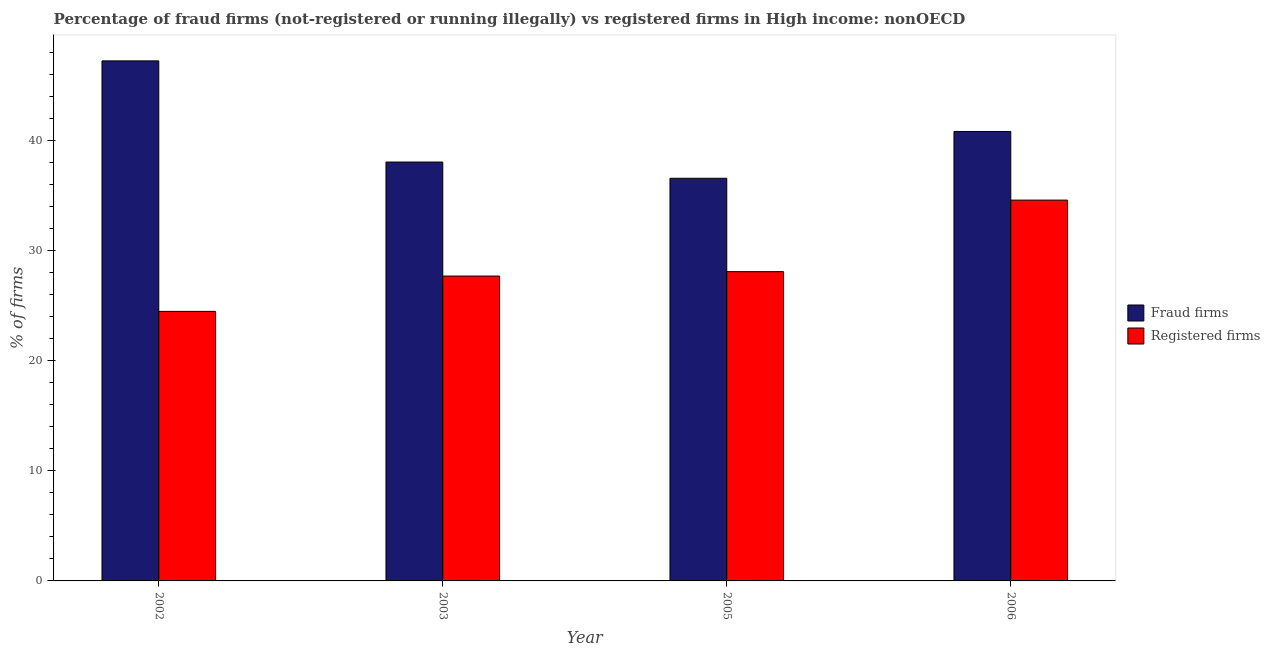Are the number of bars per tick equal to the number of legend labels?
Your response must be concise. Yes. Are the number of bars on each tick of the X-axis equal?
Your answer should be compact. Yes. How many bars are there on the 4th tick from the left?
Give a very brief answer. 2. How many bars are there on the 1st tick from the right?
Ensure brevity in your answer.  2. What is the label of the 1st group of bars from the left?
Keep it short and to the point. 2002. What is the percentage of registered firms in 2002?
Provide a short and direct response. 24.49. Across all years, what is the maximum percentage of fraud firms?
Make the answer very short. 47.25. Across all years, what is the minimum percentage of registered firms?
Provide a short and direct response. 24.49. What is the total percentage of registered firms in the graph?
Provide a succinct answer. 114.89. What is the difference between the percentage of registered firms in 2002 and that in 2005?
Your answer should be very brief. -3.61. What is the difference between the percentage of fraud firms in 2005 and the percentage of registered firms in 2003?
Give a very brief answer. -1.48. What is the average percentage of fraud firms per year?
Provide a succinct answer. 40.68. What is the ratio of the percentage of registered firms in 2003 to that in 2006?
Make the answer very short. 0.8. What is the difference between the highest and the lowest percentage of fraud firms?
Your response must be concise. 10.67. What does the 2nd bar from the left in 2003 represents?
Give a very brief answer. Registered firms. What does the 2nd bar from the right in 2003 represents?
Ensure brevity in your answer.  Fraud firms. How many years are there in the graph?
Your response must be concise. 4. What is the difference between two consecutive major ticks on the Y-axis?
Your response must be concise. 10. Are the values on the major ticks of Y-axis written in scientific E-notation?
Keep it short and to the point. No. Does the graph contain any zero values?
Provide a succinct answer. No. How many legend labels are there?
Your response must be concise. 2. How are the legend labels stacked?
Make the answer very short. Vertical. What is the title of the graph?
Your answer should be compact. Percentage of fraud firms (not-registered or running illegally) vs registered firms in High income: nonOECD. What is the label or title of the Y-axis?
Your answer should be compact. % of firms. What is the % of firms in Fraud firms in 2002?
Ensure brevity in your answer.  47.25. What is the % of firms of Registered firms in 2002?
Your answer should be compact. 24.49. What is the % of firms in Fraud firms in 2003?
Ensure brevity in your answer.  38.06. What is the % of firms of Registered firms in 2003?
Provide a succinct answer. 27.7. What is the % of firms of Fraud firms in 2005?
Provide a short and direct response. 36.58. What is the % of firms of Registered firms in 2005?
Provide a short and direct response. 28.1. What is the % of firms in Fraud firms in 2006?
Make the answer very short. 40.84. What is the % of firms in Registered firms in 2006?
Make the answer very short. 34.6. Across all years, what is the maximum % of firms of Fraud firms?
Keep it short and to the point. 47.25. Across all years, what is the maximum % of firms in Registered firms?
Make the answer very short. 34.6. Across all years, what is the minimum % of firms of Fraud firms?
Your answer should be compact. 36.58. Across all years, what is the minimum % of firms in Registered firms?
Your answer should be compact. 24.49. What is the total % of firms in Fraud firms in the graph?
Your response must be concise. 162.73. What is the total % of firms of Registered firms in the graph?
Keep it short and to the point. 114.89. What is the difference between the % of firms of Fraud firms in 2002 and that in 2003?
Your answer should be compact. 9.19. What is the difference between the % of firms in Registered firms in 2002 and that in 2003?
Your answer should be compact. -3.21. What is the difference between the % of firms in Fraud firms in 2002 and that in 2005?
Offer a terse response. 10.67. What is the difference between the % of firms in Registered firms in 2002 and that in 2005?
Make the answer very short. -3.61. What is the difference between the % of firms in Fraud firms in 2002 and that in 2006?
Offer a very short reply. 6.41. What is the difference between the % of firms of Registered firms in 2002 and that in 2006?
Provide a succinct answer. -10.11. What is the difference between the % of firms in Fraud firms in 2003 and that in 2005?
Offer a very short reply. 1.48. What is the difference between the % of firms of Registered firms in 2003 and that in 2005?
Provide a succinct answer. -0.4. What is the difference between the % of firms of Fraud firms in 2003 and that in 2006?
Your answer should be very brief. -2.78. What is the difference between the % of firms in Registered firms in 2003 and that in 2006?
Make the answer very short. -6.9. What is the difference between the % of firms of Fraud firms in 2005 and that in 2006?
Make the answer very short. -4.25. What is the difference between the % of firms of Fraud firms in 2002 and the % of firms of Registered firms in 2003?
Offer a very short reply. 19.55. What is the difference between the % of firms in Fraud firms in 2002 and the % of firms in Registered firms in 2005?
Make the answer very short. 19.15. What is the difference between the % of firms in Fraud firms in 2002 and the % of firms in Registered firms in 2006?
Give a very brief answer. 12.65. What is the difference between the % of firms of Fraud firms in 2003 and the % of firms of Registered firms in 2005?
Offer a terse response. 9.96. What is the difference between the % of firms in Fraud firms in 2003 and the % of firms in Registered firms in 2006?
Make the answer very short. 3.46. What is the difference between the % of firms in Fraud firms in 2005 and the % of firms in Registered firms in 2006?
Offer a terse response. 1.98. What is the average % of firms in Fraud firms per year?
Make the answer very short. 40.68. What is the average % of firms of Registered firms per year?
Make the answer very short. 28.72. In the year 2002, what is the difference between the % of firms of Fraud firms and % of firms of Registered firms?
Provide a succinct answer. 22.76. In the year 2003, what is the difference between the % of firms in Fraud firms and % of firms in Registered firms?
Offer a terse response. 10.36. In the year 2005, what is the difference between the % of firms in Fraud firms and % of firms in Registered firms?
Your answer should be very brief. 8.48. In the year 2006, what is the difference between the % of firms of Fraud firms and % of firms of Registered firms?
Your answer should be very brief. 6.24. What is the ratio of the % of firms in Fraud firms in 2002 to that in 2003?
Provide a succinct answer. 1.24. What is the ratio of the % of firms of Registered firms in 2002 to that in 2003?
Your response must be concise. 0.88. What is the ratio of the % of firms of Fraud firms in 2002 to that in 2005?
Your response must be concise. 1.29. What is the ratio of the % of firms of Registered firms in 2002 to that in 2005?
Ensure brevity in your answer.  0.87. What is the ratio of the % of firms of Fraud firms in 2002 to that in 2006?
Your answer should be very brief. 1.16. What is the ratio of the % of firms in Registered firms in 2002 to that in 2006?
Give a very brief answer. 0.71. What is the ratio of the % of firms in Fraud firms in 2003 to that in 2005?
Your response must be concise. 1.04. What is the ratio of the % of firms of Registered firms in 2003 to that in 2005?
Provide a succinct answer. 0.99. What is the ratio of the % of firms in Fraud firms in 2003 to that in 2006?
Make the answer very short. 0.93. What is the ratio of the % of firms in Registered firms in 2003 to that in 2006?
Offer a very short reply. 0.8. What is the ratio of the % of firms of Fraud firms in 2005 to that in 2006?
Make the answer very short. 0.9. What is the ratio of the % of firms of Registered firms in 2005 to that in 2006?
Provide a short and direct response. 0.81. What is the difference between the highest and the second highest % of firms of Fraud firms?
Keep it short and to the point. 6.41. What is the difference between the highest and the second highest % of firms in Registered firms?
Provide a short and direct response. 6.5. What is the difference between the highest and the lowest % of firms of Fraud firms?
Offer a terse response. 10.67. What is the difference between the highest and the lowest % of firms of Registered firms?
Make the answer very short. 10.11. 